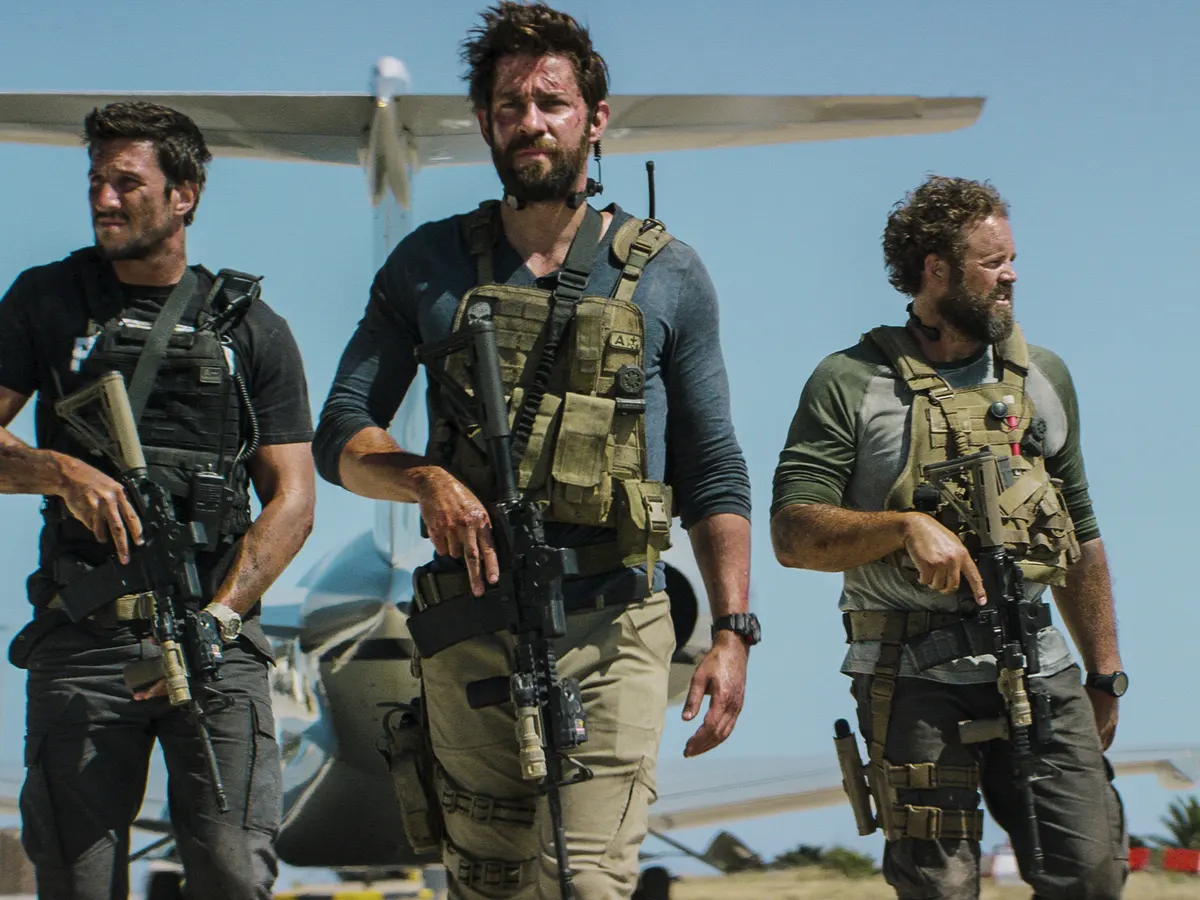What could these individuals be preparing for, given their attire and equipment? The group appears to be gearing up for a tactical operation, potentially a special forces military mission or a law enforcement endeavor. The level of preparedness, with rifles ready and focused expressions, suggests an imminent action where teamwork and precision are crucial. 